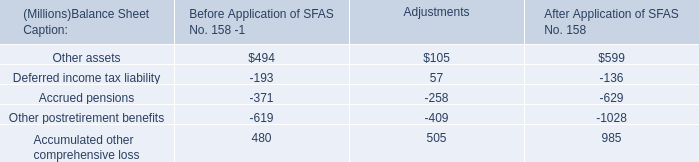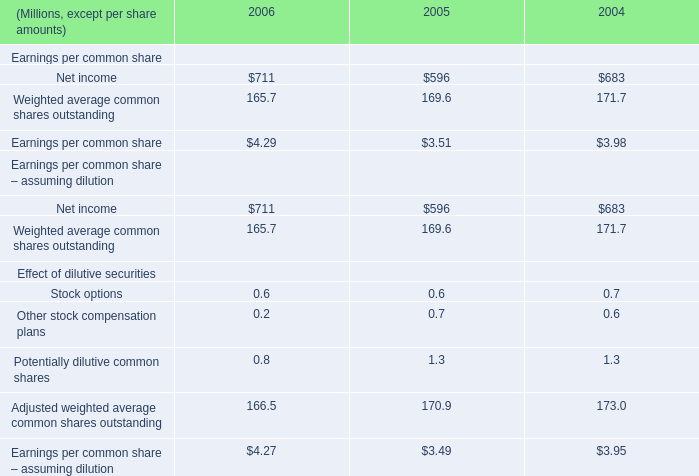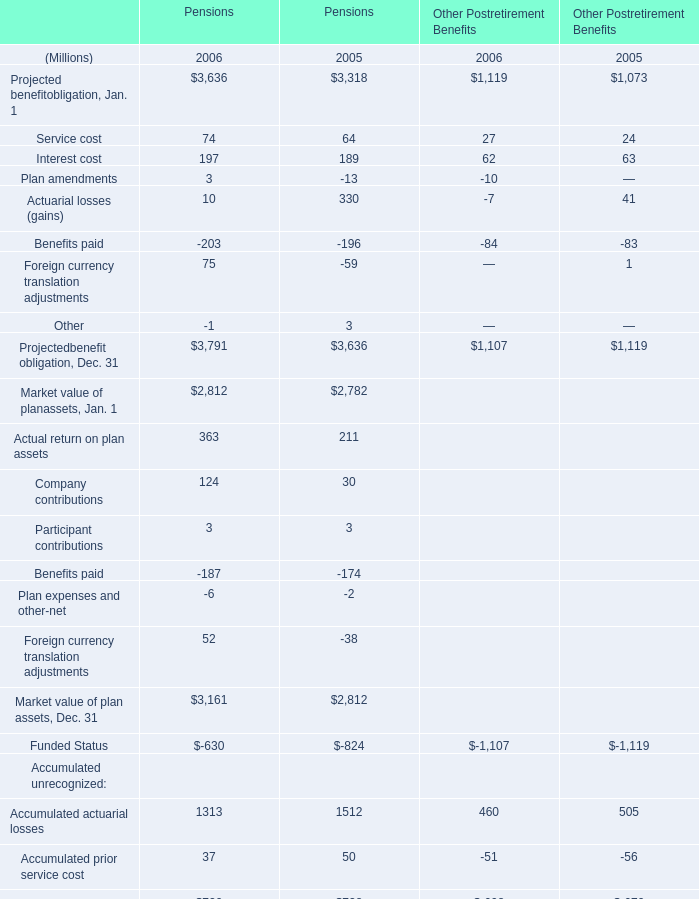Which Projected benefit obligation for pension has the second largest number in 2005 ? 
Answer: Actuarial losses (gains). 